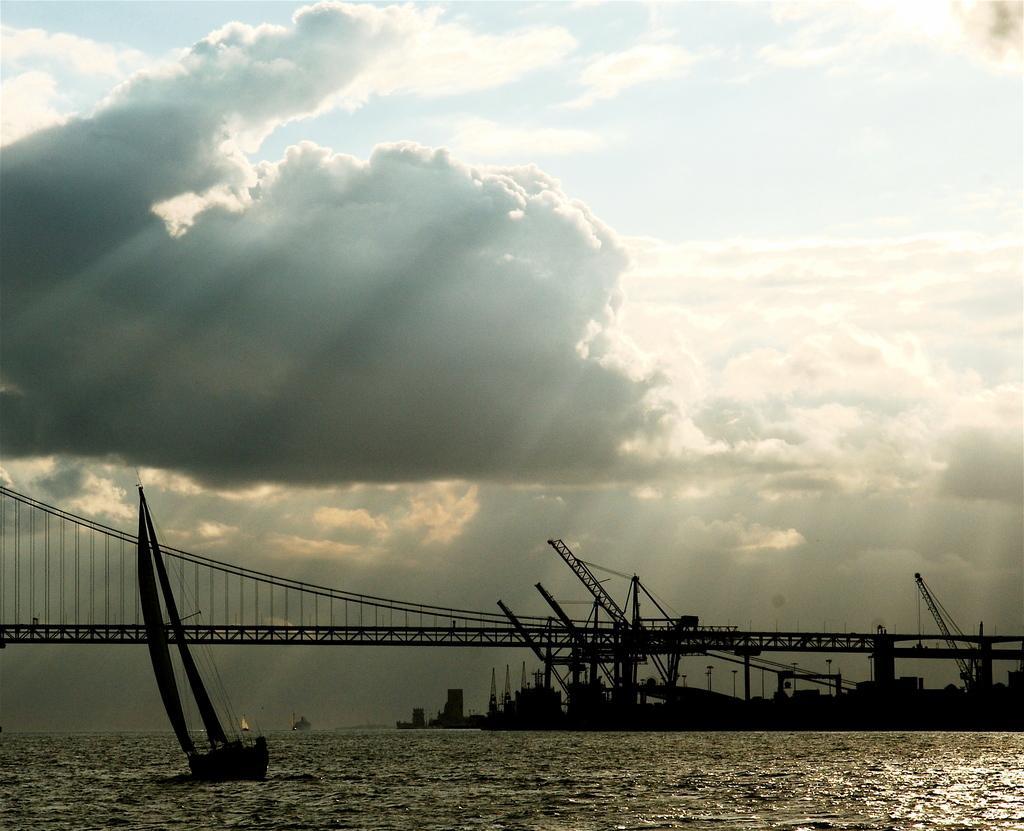Can you describe this image briefly? In this picture there is a river water in the front with sailing boat. Behind there is a iron suspension bridge with some cranes. On the top there is a sky and white clouds. 